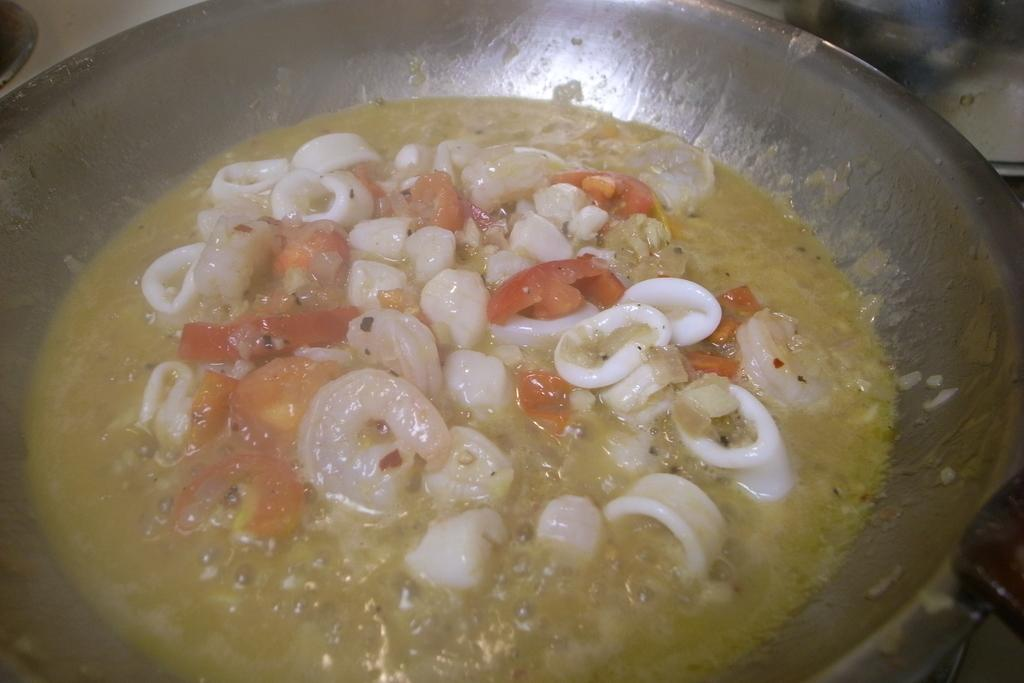What is in the bowl that is visible in the image? There is a bowl with a food item in the image. Can you describe the background of the image? The background of the image appears blurry. What type of winter sport is being played in the background of the image? There is no winter sport or any indication of winter in the image; it only features a bowl with a food item and a blurry background. 